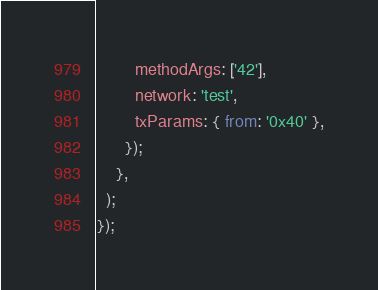Convert code to text. <code><loc_0><loc_0><loc_500><loc_500><_JavaScript_>        methodArgs: ['42'],
        network: 'test',
        txParams: { from: '0x40' },
      });
    },
  );
});
</code> 